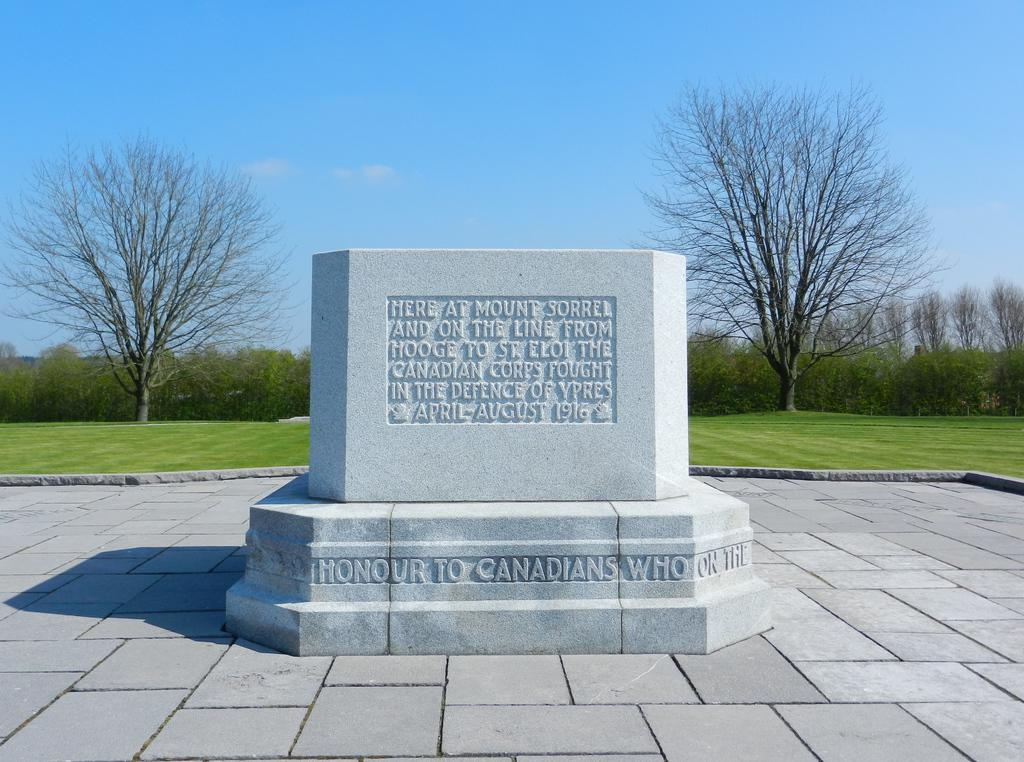What is the primary surface visible in the image? There is a floor in the image. What is written or depicted on the floor? There is a stone with text on the floor. What type of vegetation can be seen in the background of the image? There is grass and trees in the background of the image. What part of the natural environment is visible in the image? The sky is visible in the background of the image. How many bikes are being destroyed by the calculator in the image? There are no bikes or calculators present in the image. 